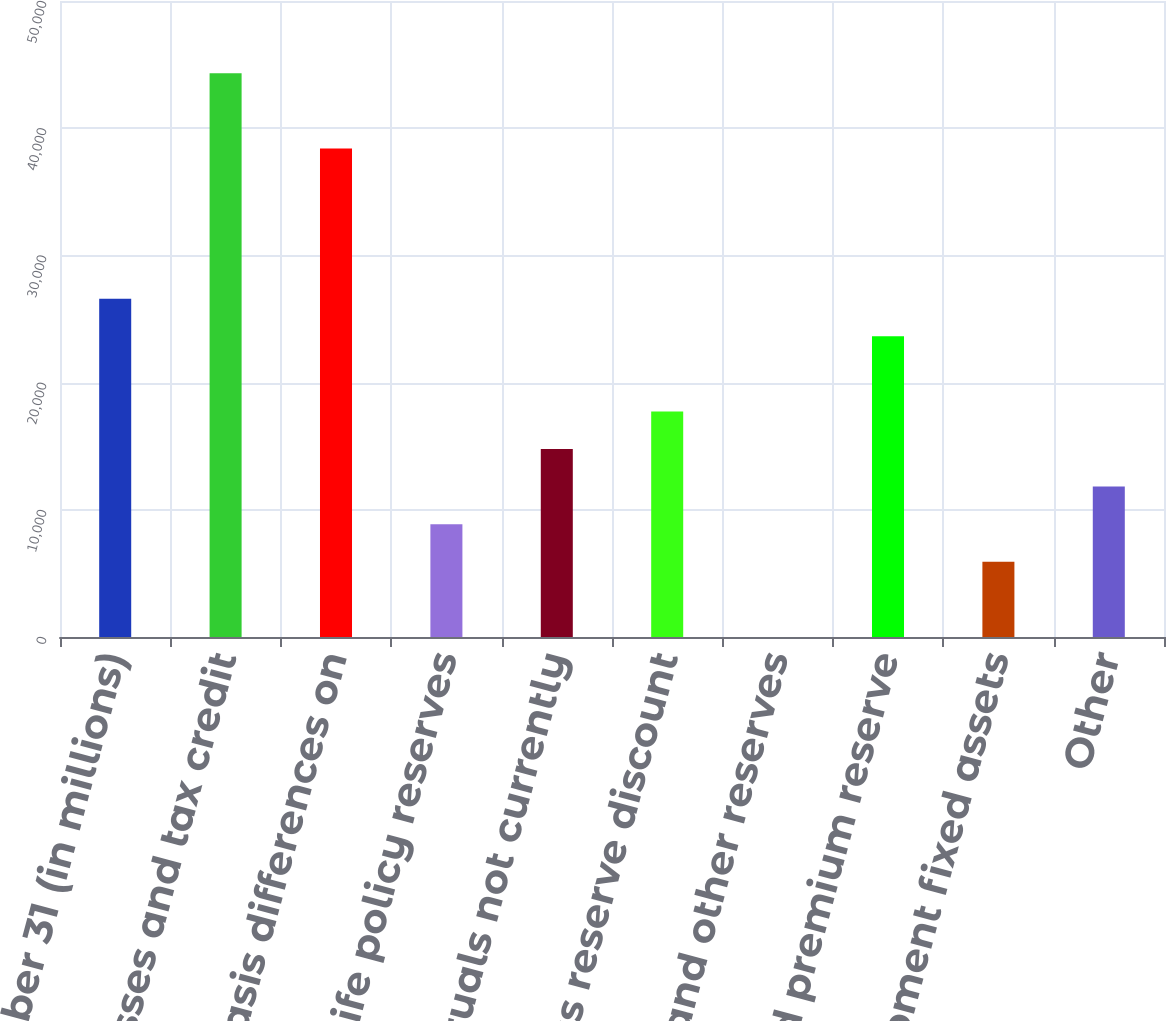Convert chart to OTSL. <chart><loc_0><loc_0><loc_500><loc_500><bar_chart><fcel>December 31 (in millions)<fcel>Losses and tax credit<fcel>Basis differences on<fcel>Life policy reserves<fcel>Accruals not currently<fcel>Loss reserve discount<fcel>Loan loss and other reserves<fcel>Unearned premium reserve<fcel>Flight equipment fixed assets<fcel>Other<nl><fcel>26592.2<fcel>44315<fcel>38407.4<fcel>8869.4<fcel>14777<fcel>17730.8<fcel>8<fcel>23638.4<fcel>5915.6<fcel>11823.2<nl></chart> 